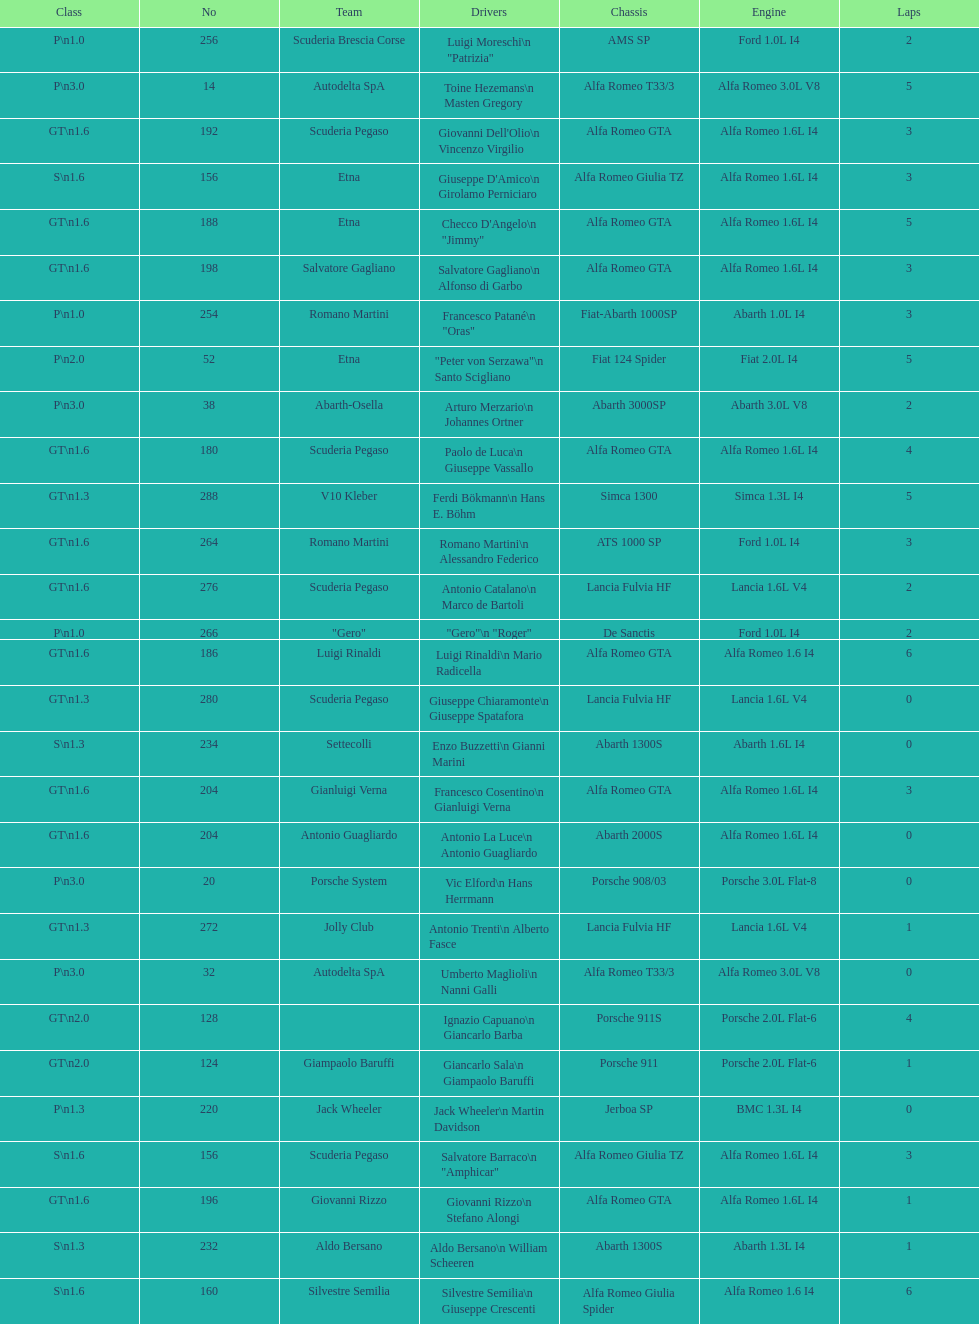Which chassis is in the middle of simca 1300 and alfa romeo gta? Porsche 911S. 